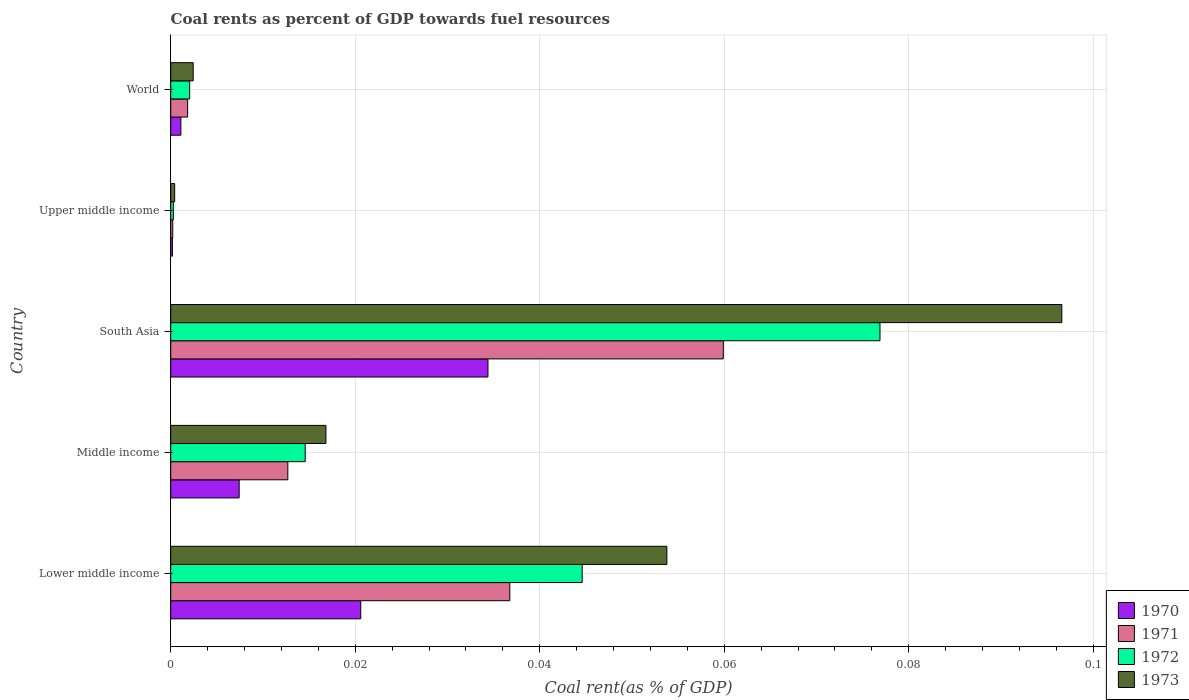Are the number of bars per tick equal to the number of legend labels?
Keep it short and to the point. Yes. How many bars are there on the 3rd tick from the top?
Provide a succinct answer. 4. How many bars are there on the 3rd tick from the bottom?
Your response must be concise. 4. In how many cases, is the number of bars for a given country not equal to the number of legend labels?
Make the answer very short. 0. What is the coal rent in 1970 in Lower middle income?
Your answer should be very brief. 0.02. Across all countries, what is the maximum coal rent in 1970?
Your answer should be very brief. 0.03. Across all countries, what is the minimum coal rent in 1973?
Give a very brief answer. 0. In which country was the coal rent in 1972 minimum?
Your response must be concise. Upper middle income. What is the total coal rent in 1970 in the graph?
Make the answer very short. 0.06. What is the difference between the coal rent in 1971 in Lower middle income and that in Middle income?
Your answer should be compact. 0.02. What is the difference between the coal rent in 1972 in Lower middle income and the coal rent in 1970 in Middle income?
Provide a short and direct response. 0.04. What is the average coal rent in 1972 per country?
Your answer should be compact. 0.03. What is the difference between the coal rent in 1971 and coal rent in 1973 in South Asia?
Offer a terse response. -0.04. In how many countries, is the coal rent in 1970 greater than 0.072 %?
Ensure brevity in your answer.  0. What is the ratio of the coal rent in 1973 in Lower middle income to that in Middle income?
Provide a short and direct response. 3.2. Is the difference between the coal rent in 1971 in Lower middle income and Middle income greater than the difference between the coal rent in 1973 in Lower middle income and Middle income?
Keep it short and to the point. No. What is the difference between the highest and the second highest coal rent in 1971?
Give a very brief answer. 0.02. What is the difference between the highest and the lowest coal rent in 1971?
Your response must be concise. 0.06. In how many countries, is the coal rent in 1970 greater than the average coal rent in 1970 taken over all countries?
Provide a short and direct response. 2. Is the sum of the coal rent in 1972 in South Asia and Upper middle income greater than the maximum coal rent in 1971 across all countries?
Provide a short and direct response. Yes. Is it the case that in every country, the sum of the coal rent in 1972 and coal rent in 1973 is greater than the sum of coal rent in 1971 and coal rent in 1970?
Make the answer very short. No. Is it the case that in every country, the sum of the coal rent in 1970 and coal rent in 1972 is greater than the coal rent in 1973?
Offer a very short reply. Yes. Are the values on the major ticks of X-axis written in scientific E-notation?
Offer a terse response. No. What is the title of the graph?
Provide a succinct answer. Coal rents as percent of GDP towards fuel resources. Does "1960" appear as one of the legend labels in the graph?
Offer a terse response. No. What is the label or title of the X-axis?
Give a very brief answer. Coal rent(as % of GDP). What is the label or title of the Y-axis?
Give a very brief answer. Country. What is the Coal rent(as % of GDP) of 1970 in Lower middle income?
Keep it short and to the point. 0.02. What is the Coal rent(as % of GDP) of 1971 in Lower middle income?
Provide a succinct answer. 0.04. What is the Coal rent(as % of GDP) in 1972 in Lower middle income?
Your response must be concise. 0.04. What is the Coal rent(as % of GDP) in 1973 in Lower middle income?
Provide a short and direct response. 0.05. What is the Coal rent(as % of GDP) of 1970 in Middle income?
Keep it short and to the point. 0.01. What is the Coal rent(as % of GDP) in 1971 in Middle income?
Give a very brief answer. 0.01. What is the Coal rent(as % of GDP) in 1972 in Middle income?
Keep it short and to the point. 0.01. What is the Coal rent(as % of GDP) of 1973 in Middle income?
Make the answer very short. 0.02. What is the Coal rent(as % of GDP) of 1970 in South Asia?
Make the answer very short. 0.03. What is the Coal rent(as % of GDP) of 1971 in South Asia?
Your response must be concise. 0.06. What is the Coal rent(as % of GDP) in 1972 in South Asia?
Provide a short and direct response. 0.08. What is the Coal rent(as % of GDP) in 1973 in South Asia?
Your response must be concise. 0.1. What is the Coal rent(as % of GDP) of 1970 in Upper middle income?
Offer a terse response. 0. What is the Coal rent(as % of GDP) of 1971 in Upper middle income?
Provide a short and direct response. 0. What is the Coal rent(as % of GDP) in 1972 in Upper middle income?
Offer a terse response. 0. What is the Coal rent(as % of GDP) of 1973 in Upper middle income?
Give a very brief answer. 0. What is the Coal rent(as % of GDP) in 1970 in World?
Offer a very short reply. 0. What is the Coal rent(as % of GDP) of 1971 in World?
Offer a very short reply. 0. What is the Coal rent(as % of GDP) of 1972 in World?
Your answer should be very brief. 0. What is the Coal rent(as % of GDP) in 1973 in World?
Give a very brief answer. 0. Across all countries, what is the maximum Coal rent(as % of GDP) of 1970?
Keep it short and to the point. 0.03. Across all countries, what is the maximum Coal rent(as % of GDP) of 1971?
Offer a terse response. 0.06. Across all countries, what is the maximum Coal rent(as % of GDP) in 1972?
Ensure brevity in your answer.  0.08. Across all countries, what is the maximum Coal rent(as % of GDP) of 1973?
Make the answer very short. 0.1. Across all countries, what is the minimum Coal rent(as % of GDP) in 1970?
Offer a terse response. 0. Across all countries, what is the minimum Coal rent(as % of GDP) in 1971?
Ensure brevity in your answer.  0. Across all countries, what is the minimum Coal rent(as % of GDP) of 1972?
Your response must be concise. 0. Across all countries, what is the minimum Coal rent(as % of GDP) of 1973?
Provide a short and direct response. 0. What is the total Coal rent(as % of GDP) of 1970 in the graph?
Give a very brief answer. 0.06. What is the total Coal rent(as % of GDP) in 1971 in the graph?
Give a very brief answer. 0.11. What is the total Coal rent(as % of GDP) in 1972 in the graph?
Ensure brevity in your answer.  0.14. What is the total Coal rent(as % of GDP) of 1973 in the graph?
Offer a terse response. 0.17. What is the difference between the Coal rent(as % of GDP) in 1970 in Lower middle income and that in Middle income?
Make the answer very short. 0.01. What is the difference between the Coal rent(as % of GDP) of 1971 in Lower middle income and that in Middle income?
Your answer should be compact. 0.02. What is the difference between the Coal rent(as % of GDP) of 1973 in Lower middle income and that in Middle income?
Ensure brevity in your answer.  0.04. What is the difference between the Coal rent(as % of GDP) of 1970 in Lower middle income and that in South Asia?
Give a very brief answer. -0.01. What is the difference between the Coal rent(as % of GDP) in 1971 in Lower middle income and that in South Asia?
Your response must be concise. -0.02. What is the difference between the Coal rent(as % of GDP) in 1972 in Lower middle income and that in South Asia?
Make the answer very short. -0.03. What is the difference between the Coal rent(as % of GDP) of 1973 in Lower middle income and that in South Asia?
Keep it short and to the point. -0.04. What is the difference between the Coal rent(as % of GDP) of 1970 in Lower middle income and that in Upper middle income?
Your answer should be compact. 0.02. What is the difference between the Coal rent(as % of GDP) of 1971 in Lower middle income and that in Upper middle income?
Offer a terse response. 0.04. What is the difference between the Coal rent(as % of GDP) of 1972 in Lower middle income and that in Upper middle income?
Make the answer very short. 0.04. What is the difference between the Coal rent(as % of GDP) of 1973 in Lower middle income and that in Upper middle income?
Ensure brevity in your answer.  0.05. What is the difference between the Coal rent(as % of GDP) of 1970 in Lower middle income and that in World?
Provide a short and direct response. 0.02. What is the difference between the Coal rent(as % of GDP) in 1971 in Lower middle income and that in World?
Give a very brief answer. 0.03. What is the difference between the Coal rent(as % of GDP) in 1972 in Lower middle income and that in World?
Keep it short and to the point. 0.04. What is the difference between the Coal rent(as % of GDP) of 1973 in Lower middle income and that in World?
Make the answer very short. 0.05. What is the difference between the Coal rent(as % of GDP) of 1970 in Middle income and that in South Asia?
Keep it short and to the point. -0.03. What is the difference between the Coal rent(as % of GDP) of 1971 in Middle income and that in South Asia?
Keep it short and to the point. -0.05. What is the difference between the Coal rent(as % of GDP) in 1972 in Middle income and that in South Asia?
Ensure brevity in your answer.  -0.06. What is the difference between the Coal rent(as % of GDP) in 1973 in Middle income and that in South Asia?
Provide a succinct answer. -0.08. What is the difference between the Coal rent(as % of GDP) in 1970 in Middle income and that in Upper middle income?
Your answer should be very brief. 0.01. What is the difference between the Coal rent(as % of GDP) in 1971 in Middle income and that in Upper middle income?
Your answer should be compact. 0.01. What is the difference between the Coal rent(as % of GDP) of 1972 in Middle income and that in Upper middle income?
Offer a very short reply. 0.01. What is the difference between the Coal rent(as % of GDP) in 1973 in Middle income and that in Upper middle income?
Your answer should be very brief. 0.02. What is the difference between the Coal rent(as % of GDP) in 1970 in Middle income and that in World?
Your answer should be compact. 0.01. What is the difference between the Coal rent(as % of GDP) of 1971 in Middle income and that in World?
Provide a short and direct response. 0.01. What is the difference between the Coal rent(as % of GDP) of 1972 in Middle income and that in World?
Your response must be concise. 0.01. What is the difference between the Coal rent(as % of GDP) in 1973 in Middle income and that in World?
Ensure brevity in your answer.  0.01. What is the difference between the Coal rent(as % of GDP) in 1970 in South Asia and that in Upper middle income?
Your answer should be compact. 0.03. What is the difference between the Coal rent(as % of GDP) in 1971 in South Asia and that in Upper middle income?
Ensure brevity in your answer.  0.06. What is the difference between the Coal rent(as % of GDP) in 1972 in South Asia and that in Upper middle income?
Provide a succinct answer. 0.08. What is the difference between the Coal rent(as % of GDP) of 1973 in South Asia and that in Upper middle income?
Give a very brief answer. 0.1. What is the difference between the Coal rent(as % of GDP) of 1971 in South Asia and that in World?
Your answer should be very brief. 0.06. What is the difference between the Coal rent(as % of GDP) in 1972 in South Asia and that in World?
Your answer should be very brief. 0.07. What is the difference between the Coal rent(as % of GDP) of 1973 in South Asia and that in World?
Offer a very short reply. 0.09. What is the difference between the Coal rent(as % of GDP) of 1970 in Upper middle income and that in World?
Give a very brief answer. -0. What is the difference between the Coal rent(as % of GDP) of 1971 in Upper middle income and that in World?
Offer a very short reply. -0. What is the difference between the Coal rent(as % of GDP) of 1972 in Upper middle income and that in World?
Your answer should be very brief. -0. What is the difference between the Coal rent(as % of GDP) in 1973 in Upper middle income and that in World?
Your answer should be compact. -0. What is the difference between the Coal rent(as % of GDP) of 1970 in Lower middle income and the Coal rent(as % of GDP) of 1971 in Middle income?
Give a very brief answer. 0.01. What is the difference between the Coal rent(as % of GDP) in 1970 in Lower middle income and the Coal rent(as % of GDP) in 1972 in Middle income?
Your answer should be very brief. 0.01. What is the difference between the Coal rent(as % of GDP) of 1970 in Lower middle income and the Coal rent(as % of GDP) of 1973 in Middle income?
Keep it short and to the point. 0. What is the difference between the Coal rent(as % of GDP) in 1971 in Lower middle income and the Coal rent(as % of GDP) in 1972 in Middle income?
Your response must be concise. 0.02. What is the difference between the Coal rent(as % of GDP) in 1971 in Lower middle income and the Coal rent(as % of GDP) in 1973 in Middle income?
Your answer should be very brief. 0.02. What is the difference between the Coal rent(as % of GDP) of 1972 in Lower middle income and the Coal rent(as % of GDP) of 1973 in Middle income?
Make the answer very short. 0.03. What is the difference between the Coal rent(as % of GDP) of 1970 in Lower middle income and the Coal rent(as % of GDP) of 1971 in South Asia?
Offer a very short reply. -0.04. What is the difference between the Coal rent(as % of GDP) in 1970 in Lower middle income and the Coal rent(as % of GDP) in 1972 in South Asia?
Your answer should be very brief. -0.06. What is the difference between the Coal rent(as % of GDP) in 1970 in Lower middle income and the Coal rent(as % of GDP) in 1973 in South Asia?
Your response must be concise. -0.08. What is the difference between the Coal rent(as % of GDP) of 1971 in Lower middle income and the Coal rent(as % of GDP) of 1972 in South Asia?
Offer a terse response. -0.04. What is the difference between the Coal rent(as % of GDP) of 1971 in Lower middle income and the Coal rent(as % of GDP) of 1973 in South Asia?
Offer a terse response. -0.06. What is the difference between the Coal rent(as % of GDP) of 1972 in Lower middle income and the Coal rent(as % of GDP) of 1973 in South Asia?
Offer a very short reply. -0.05. What is the difference between the Coal rent(as % of GDP) in 1970 in Lower middle income and the Coal rent(as % of GDP) in 1971 in Upper middle income?
Provide a short and direct response. 0.02. What is the difference between the Coal rent(as % of GDP) of 1970 in Lower middle income and the Coal rent(as % of GDP) of 1972 in Upper middle income?
Offer a terse response. 0.02. What is the difference between the Coal rent(as % of GDP) of 1970 in Lower middle income and the Coal rent(as % of GDP) of 1973 in Upper middle income?
Provide a short and direct response. 0.02. What is the difference between the Coal rent(as % of GDP) of 1971 in Lower middle income and the Coal rent(as % of GDP) of 1972 in Upper middle income?
Your response must be concise. 0.04. What is the difference between the Coal rent(as % of GDP) of 1971 in Lower middle income and the Coal rent(as % of GDP) of 1973 in Upper middle income?
Your answer should be compact. 0.04. What is the difference between the Coal rent(as % of GDP) in 1972 in Lower middle income and the Coal rent(as % of GDP) in 1973 in Upper middle income?
Make the answer very short. 0.04. What is the difference between the Coal rent(as % of GDP) of 1970 in Lower middle income and the Coal rent(as % of GDP) of 1971 in World?
Offer a very short reply. 0.02. What is the difference between the Coal rent(as % of GDP) of 1970 in Lower middle income and the Coal rent(as % of GDP) of 1972 in World?
Ensure brevity in your answer.  0.02. What is the difference between the Coal rent(as % of GDP) of 1970 in Lower middle income and the Coal rent(as % of GDP) of 1973 in World?
Your answer should be very brief. 0.02. What is the difference between the Coal rent(as % of GDP) of 1971 in Lower middle income and the Coal rent(as % of GDP) of 1972 in World?
Provide a succinct answer. 0.03. What is the difference between the Coal rent(as % of GDP) of 1971 in Lower middle income and the Coal rent(as % of GDP) of 1973 in World?
Your answer should be very brief. 0.03. What is the difference between the Coal rent(as % of GDP) of 1972 in Lower middle income and the Coal rent(as % of GDP) of 1973 in World?
Give a very brief answer. 0.04. What is the difference between the Coal rent(as % of GDP) in 1970 in Middle income and the Coal rent(as % of GDP) in 1971 in South Asia?
Provide a short and direct response. -0.05. What is the difference between the Coal rent(as % of GDP) of 1970 in Middle income and the Coal rent(as % of GDP) of 1972 in South Asia?
Your answer should be very brief. -0.07. What is the difference between the Coal rent(as % of GDP) in 1970 in Middle income and the Coal rent(as % of GDP) in 1973 in South Asia?
Your answer should be compact. -0.09. What is the difference between the Coal rent(as % of GDP) of 1971 in Middle income and the Coal rent(as % of GDP) of 1972 in South Asia?
Offer a very short reply. -0.06. What is the difference between the Coal rent(as % of GDP) in 1971 in Middle income and the Coal rent(as % of GDP) in 1973 in South Asia?
Give a very brief answer. -0.08. What is the difference between the Coal rent(as % of GDP) in 1972 in Middle income and the Coal rent(as % of GDP) in 1973 in South Asia?
Offer a terse response. -0.08. What is the difference between the Coal rent(as % of GDP) of 1970 in Middle income and the Coal rent(as % of GDP) of 1971 in Upper middle income?
Your response must be concise. 0.01. What is the difference between the Coal rent(as % of GDP) in 1970 in Middle income and the Coal rent(as % of GDP) in 1972 in Upper middle income?
Ensure brevity in your answer.  0.01. What is the difference between the Coal rent(as % of GDP) of 1970 in Middle income and the Coal rent(as % of GDP) of 1973 in Upper middle income?
Offer a very short reply. 0.01. What is the difference between the Coal rent(as % of GDP) of 1971 in Middle income and the Coal rent(as % of GDP) of 1972 in Upper middle income?
Give a very brief answer. 0.01. What is the difference between the Coal rent(as % of GDP) in 1971 in Middle income and the Coal rent(as % of GDP) in 1973 in Upper middle income?
Keep it short and to the point. 0.01. What is the difference between the Coal rent(as % of GDP) of 1972 in Middle income and the Coal rent(as % of GDP) of 1973 in Upper middle income?
Ensure brevity in your answer.  0.01. What is the difference between the Coal rent(as % of GDP) of 1970 in Middle income and the Coal rent(as % of GDP) of 1971 in World?
Keep it short and to the point. 0.01. What is the difference between the Coal rent(as % of GDP) of 1970 in Middle income and the Coal rent(as % of GDP) of 1972 in World?
Make the answer very short. 0.01. What is the difference between the Coal rent(as % of GDP) of 1970 in Middle income and the Coal rent(as % of GDP) of 1973 in World?
Offer a very short reply. 0.01. What is the difference between the Coal rent(as % of GDP) in 1971 in Middle income and the Coal rent(as % of GDP) in 1972 in World?
Give a very brief answer. 0.01. What is the difference between the Coal rent(as % of GDP) of 1971 in Middle income and the Coal rent(as % of GDP) of 1973 in World?
Offer a very short reply. 0.01. What is the difference between the Coal rent(as % of GDP) in 1972 in Middle income and the Coal rent(as % of GDP) in 1973 in World?
Give a very brief answer. 0.01. What is the difference between the Coal rent(as % of GDP) of 1970 in South Asia and the Coal rent(as % of GDP) of 1971 in Upper middle income?
Offer a very short reply. 0.03. What is the difference between the Coal rent(as % of GDP) in 1970 in South Asia and the Coal rent(as % of GDP) in 1972 in Upper middle income?
Your answer should be very brief. 0.03. What is the difference between the Coal rent(as % of GDP) in 1970 in South Asia and the Coal rent(as % of GDP) in 1973 in Upper middle income?
Your answer should be very brief. 0.03. What is the difference between the Coal rent(as % of GDP) in 1971 in South Asia and the Coal rent(as % of GDP) in 1972 in Upper middle income?
Make the answer very short. 0.06. What is the difference between the Coal rent(as % of GDP) of 1971 in South Asia and the Coal rent(as % of GDP) of 1973 in Upper middle income?
Provide a succinct answer. 0.06. What is the difference between the Coal rent(as % of GDP) in 1972 in South Asia and the Coal rent(as % of GDP) in 1973 in Upper middle income?
Keep it short and to the point. 0.08. What is the difference between the Coal rent(as % of GDP) of 1970 in South Asia and the Coal rent(as % of GDP) of 1971 in World?
Provide a short and direct response. 0.03. What is the difference between the Coal rent(as % of GDP) of 1970 in South Asia and the Coal rent(as % of GDP) of 1972 in World?
Give a very brief answer. 0.03. What is the difference between the Coal rent(as % of GDP) of 1970 in South Asia and the Coal rent(as % of GDP) of 1973 in World?
Your answer should be compact. 0.03. What is the difference between the Coal rent(as % of GDP) of 1971 in South Asia and the Coal rent(as % of GDP) of 1972 in World?
Offer a terse response. 0.06. What is the difference between the Coal rent(as % of GDP) in 1971 in South Asia and the Coal rent(as % of GDP) in 1973 in World?
Provide a succinct answer. 0.06. What is the difference between the Coal rent(as % of GDP) of 1972 in South Asia and the Coal rent(as % of GDP) of 1973 in World?
Your response must be concise. 0.07. What is the difference between the Coal rent(as % of GDP) of 1970 in Upper middle income and the Coal rent(as % of GDP) of 1971 in World?
Your response must be concise. -0. What is the difference between the Coal rent(as % of GDP) of 1970 in Upper middle income and the Coal rent(as % of GDP) of 1972 in World?
Keep it short and to the point. -0. What is the difference between the Coal rent(as % of GDP) of 1970 in Upper middle income and the Coal rent(as % of GDP) of 1973 in World?
Offer a terse response. -0. What is the difference between the Coal rent(as % of GDP) of 1971 in Upper middle income and the Coal rent(as % of GDP) of 1972 in World?
Give a very brief answer. -0. What is the difference between the Coal rent(as % of GDP) in 1971 in Upper middle income and the Coal rent(as % of GDP) in 1973 in World?
Your response must be concise. -0. What is the difference between the Coal rent(as % of GDP) in 1972 in Upper middle income and the Coal rent(as % of GDP) in 1973 in World?
Your response must be concise. -0. What is the average Coal rent(as % of GDP) of 1970 per country?
Offer a terse response. 0.01. What is the average Coal rent(as % of GDP) of 1971 per country?
Your answer should be very brief. 0.02. What is the average Coal rent(as % of GDP) of 1972 per country?
Give a very brief answer. 0.03. What is the average Coal rent(as % of GDP) in 1973 per country?
Make the answer very short. 0.03. What is the difference between the Coal rent(as % of GDP) in 1970 and Coal rent(as % of GDP) in 1971 in Lower middle income?
Provide a short and direct response. -0.02. What is the difference between the Coal rent(as % of GDP) of 1970 and Coal rent(as % of GDP) of 1972 in Lower middle income?
Keep it short and to the point. -0.02. What is the difference between the Coal rent(as % of GDP) in 1970 and Coal rent(as % of GDP) in 1973 in Lower middle income?
Ensure brevity in your answer.  -0.03. What is the difference between the Coal rent(as % of GDP) of 1971 and Coal rent(as % of GDP) of 1972 in Lower middle income?
Make the answer very short. -0.01. What is the difference between the Coal rent(as % of GDP) of 1971 and Coal rent(as % of GDP) of 1973 in Lower middle income?
Provide a short and direct response. -0.02. What is the difference between the Coal rent(as % of GDP) in 1972 and Coal rent(as % of GDP) in 1973 in Lower middle income?
Keep it short and to the point. -0.01. What is the difference between the Coal rent(as % of GDP) in 1970 and Coal rent(as % of GDP) in 1971 in Middle income?
Your answer should be very brief. -0.01. What is the difference between the Coal rent(as % of GDP) of 1970 and Coal rent(as % of GDP) of 1972 in Middle income?
Keep it short and to the point. -0.01. What is the difference between the Coal rent(as % of GDP) in 1970 and Coal rent(as % of GDP) in 1973 in Middle income?
Give a very brief answer. -0.01. What is the difference between the Coal rent(as % of GDP) of 1971 and Coal rent(as % of GDP) of 1972 in Middle income?
Ensure brevity in your answer.  -0. What is the difference between the Coal rent(as % of GDP) in 1971 and Coal rent(as % of GDP) in 1973 in Middle income?
Provide a short and direct response. -0. What is the difference between the Coal rent(as % of GDP) in 1972 and Coal rent(as % of GDP) in 1973 in Middle income?
Provide a short and direct response. -0. What is the difference between the Coal rent(as % of GDP) of 1970 and Coal rent(as % of GDP) of 1971 in South Asia?
Your answer should be very brief. -0.03. What is the difference between the Coal rent(as % of GDP) in 1970 and Coal rent(as % of GDP) in 1972 in South Asia?
Provide a short and direct response. -0.04. What is the difference between the Coal rent(as % of GDP) in 1970 and Coal rent(as % of GDP) in 1973 in South Asia?
Offer a very short reply. -0.06. What is the difference between the Coal rent(as % of GDP) of 1971 and Coal rent(as % of GDP) of 1972 in South Asia?
Your answer should be very brief. -0.02. What is the difference between the Coal rent(as % of GDP) in 1971 and Coal rent(as % of GDP) in 1973 in South Asia?
Ensure brevity in your answer.  -0.04. What is the difference between the Coal rent(as % of GDP) in 1972 and Coal rent(as % of GDP) in 1973 in South Asia?
Ensure brevity in your answer.  -0.02. What is the difference between the Coal rent(as % of GDP) of 1970 and Coal rent(as % of GDP) of 1972 in Upper middle income?
Ensure brevity in your answer.  -0. What is the difference between the Coal rent(as % of GDP) of 1970 and Coal rent(as % of GDP) of 1973 in Upper middle income?
Offer a terse response. -0. What is the difference between the Coal rent(as % of GDP) of 1971 and Coal rent(as % of GDP) of 1972 in Upper middle income?
Provide a succinct answer. -0. What is the difference between the Coal rent(as % of GDP) in 1971 and Coal rent(as % of GDP) in 1973 in Upper middle income?
Ensure brevity in your answer.  -0. What is the difference between the Coal rent(as % of GDP) of 1972 and Coal rent(as % of GDP) of 1973 in Upper middle income?
Provide a short and direct response. -0. What is the difference between the Coal rent(as % of GDP) in 1970 and Coal rent(as % of GDP) in 1971 in World?
Give a very brief answer. -0. What is the difference between the Coal rent(as % of GDP) of 1970 and Coal rent(as % of GDP) of 1972 in World?
Your answer should be very brief. -0. What is the difference between the Coal rent(as % of GDP) in 1970 and Coal rent(as % of GDP) in 1973 in World?
Your response must be concise. -0. What is the difference between the Coal rent(as % of GDP) of 1971 and Coal rent(as % of GDP) of 1972 in World?
Your response must be concise. -0. What is the difference between the Coal rent(as % of GDP) of 1971 and Coal rent(as % of GDP) of 1973 in World?
Your response must be concise. -0. What is the difference between the Coal rent(as % of GDP) in 1972 and Coal rent(as % of GDP) in 1973 in World?
Your response must be concise. -0. What is the ratio of the Coal rent(as % of GDP) of 1970 in Lower middle income to that in Middle income?
Your answer should be very brief. 2.78. What is the ratio of the Coal rent(as % of GDP) of 1971 in Lower middle income to that in Middle income?
Offer a terse response. 2.9. What is the ratio of the Coal rent(as % of GDP) in 1972 in Lower middle income to that in Middle income?
Provide a short and direct response. 3.06. What is the ratio of the Coal rent(as % of GDP) in 1973 in Lower middle income to that in Middle income?
Keep it short and to the point. 3.2. What is the ratio of the Coal rent(as % of GDP) in 1970 in Lower middle income to that in South Asia?
Ensure brevity in your answer.  0.6. What is the ratio of the Coal rent(as % of GDP) of 1971 in Lower middle income to that in South Asia?
Offer a very short reply. 0.61. What is the ratio of the Coal rent(as % of GDP) in 1972 in Lower middle income to that in South Asia?
Your answer should be very brief. 0.58. What is the ratio of the Coal rent(as % of GDP) of 1973 in Lower middle income to that in South Asia?
Your answer should be very brief. 0.56. What is the ratio of the Coal rent(as % of GDP) of 1970 in Lower middle income to that in Upper middle income?
Your answer should be compact. 112.03. What is the ratio of the Coal rent(as % of GDP) of 1971 in Lower middle income to that in Upper middle income?
Your answer should be very brief. 167.98. What is the ratio of the Coal rent(as % of GDP) in 1972 in Lower middle income to that in Upper middle income?
Ensure brevity in your answer.  156.82. What is the ratio of the Coal rent(as % of GDP) of 1973 in Lower middle income to that in Upper middle income?
Your response must be concise. 124.82. What is the ratio of the Coal rent(as % of GDP) in 1970 in Lower middle income to that in World?
Offer a terse response. 18.71. What is the ratio of the Coal rent(as % of GDP) of 1971 in Lower middle income to that in World?
Provide a succinct answer. 20.06. What is the ratio of the Coal rent(as % of GDP) in 1972 in Lower middle income to that in World?
Provide a short and direct response. 21.7. What is the ratio of the Coal rent(as % of GDP) in 1973 in Lower middle income to that in World?
Provide a succinct answer. 22.07. What is the ratio of the Coal rent(as % of GDP) in 1970 in Middle income to that in South Asia?
Provide a succinct answer. 0.22. What is the ratio of the Coal rent(as % of GDP) in 1971 in Middle income to that in South Asia?
Offer a terse response. 0.21. What is the ratio of the Coal rent(as % of GDP) of 1972 in Middle income to that in South Asia?
Make the answer very short. 0.19. What is the ratio of the Coal rent(as % of GDP) in 1973 in Middle income to that in South Asia?
Your response must be concise. 0.17. What is the ratio of the Coal rent(as % of GDP) of 1970 in Middle income to that in Upper middle income?
Give a very brief answer. 40.36. What is the ratio of the Coal rent(as % of GDP) in 1971 in Middle income to that in Upper middle income?
Make the answer very short. 58.01. What is the ratio of the Coal rent(as % of GDP) of 1972 in Middle income to that in Upper middle income?
Give a very brief answer. 51.25. What is the ratio of the Coal rent(as % of GDP) in 1973 in Middle income to that in Upper middle income?
Make the answer very short. 39.04. What is the ratio of the Coal rent(as % of GDP) of 1970 in Middle income to that in World?
Your answer should be very brief. 6.74. What is the ratio of the Coal rent(as % of GDP) in 1971 in Middle income to that in World?
Your response must be concise. 6.93. What is the ratio of the Coal rent(as % of GDP) in 1972 in Middle income to that in World?
Your response must be concise. 7.09. What is the ratio of the Coal rent(as % of GDP) of 1973 in Middle income to that in World?
Provide a succinct answer. 6.91. What is the ratio of the Coal rent(as % of GDP) of 1970 in South Asia to that in Upper middle income?
Your answer should be compact. 187.05. What is the ratio of the Coal rent(as % of GDP) of 1971 in South Asia to that in Upper middle income?
Ensure brevity in your answer.  273.74. What is the ratio of the Coal rent(as % of GDP) of 1972 in South Asia to that in Upper middle income?
Offer a terse response. 270.32. What is the ratio of the Coal rent(as % of GDP) in 1973 in South Asia to that in Upper middle income?
Provide a short and direct response. 224.18. What is the ratio of the Coal rent(as % of GDP) of 1970 in South Asia to that in World?
Ensure brevity in your answer.  31.24. What is the ratio of the Coal rent(as % of GDP) of 1971 in South Asia to that in World?
Your answer should be compact. 32.69. What is the ratio of the Coal rent(as % of GDP) in 1972 in South Asia to that in World?
Provide a short and direct response. 37.41. What is the ratio of the Coal rent(as % of GDP) in 1973 in South Asia to that in World?
Keep it short and to the point. 39.65. What is the ratio of the Coal rent(as % of GDP) of 1970 in Upper middle income to that in World?
Your answer should be very brief. 0.17. What is the ratio of the Coal rent(as % of GDP) of 1971 in Upper middle income to that in World?
Make the answer very short. 0.12. What is the ratio of the Coal rent(as % of GDP) of 1972 in Upper middle income to that in World?
Make the answer very short. 0.14. What is the ratio of the Coal rent(as % of GDP) in 1973 in Upper middle income to that in World?
Give a very brief answer. 0.18. What is the difference between the highest and the second highest Coal rent(as % of GDP) of 1970?
Ensure brevity in your answer.  0.01. What is the difference between the highest and the second highest Coal rent(as % of GDP) in 1971?
Your response must be concise. 0.02. What is the difference between the highest and the second highest Coal rent(as % of GDP) of 1972?
Make the answer very short. 0.03. What is the difference between the highest and the second highest Coal rent(as % of GDP) in 1973?
Your response must be concise. 0.04. What is the difference between the highest and the lowest Coal rent(as % of GDP) of 1970?
Provide a short and direct response. 0.03. What is the difference between the highest and the lowest Coal rent(as % of GDP) in 1971?
Offer a very short reply. 0.06. What is the difference between the highest and the lowest Coal rent(as % of GDP) of 1972?
Make the answer very short. 0.08. What is the difference between the highest and the lowest Coal rent(as % of GDP) of 1973?
Give a very brief answer. 0.1. 